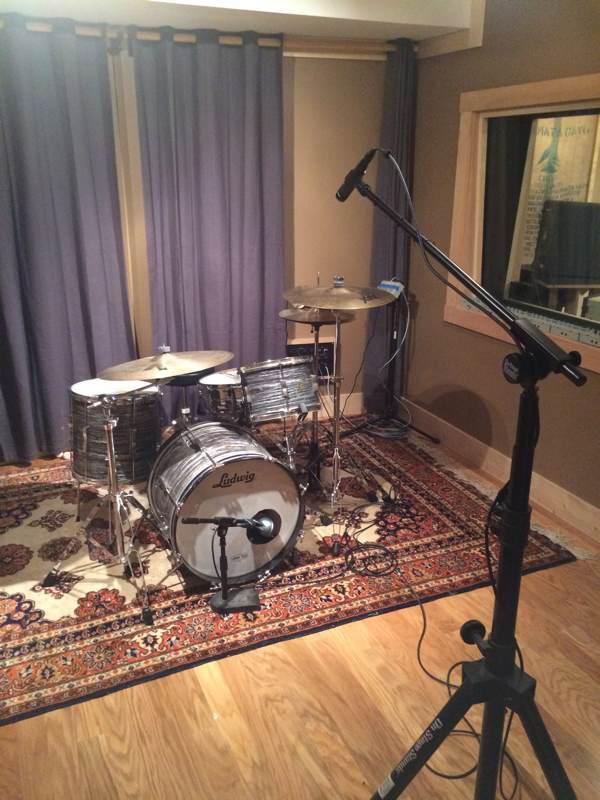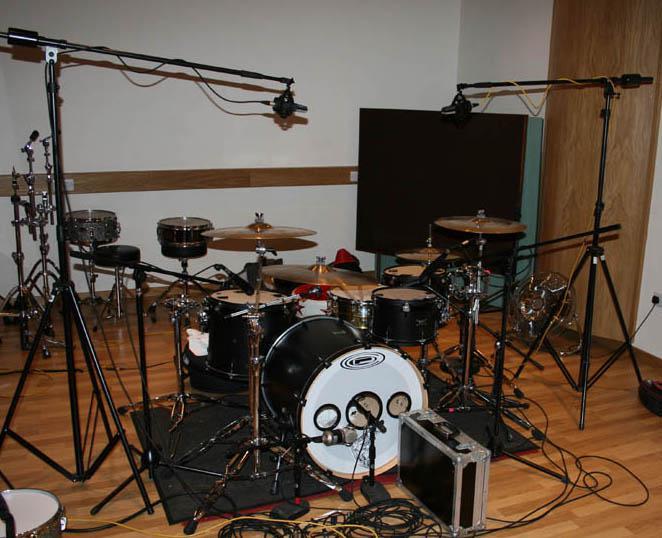The first image is the image on the left, the second image is the image on the right. Assess this claim about the two images: "The drumset sits on a rectangular rug in one of the images.". Correct or not? Answer yes or no. Yes. The first image is the image on the left, the second image is the image on the right. Assess this claim about the two images: "There is a kick drum with white skin.". Correct or not? Answer yes or no. Yes. 